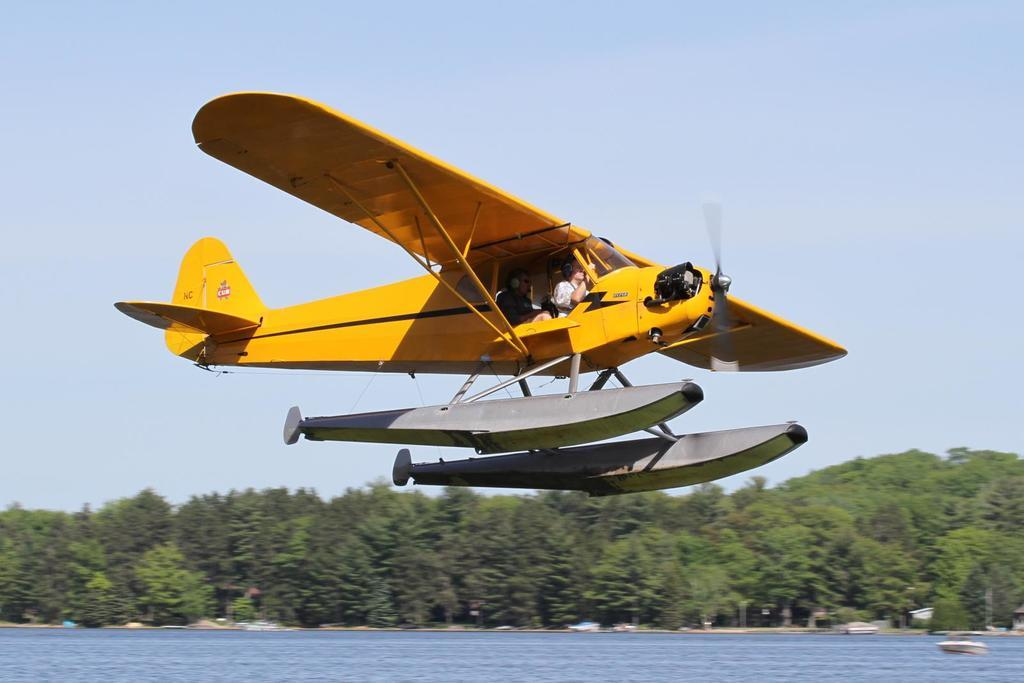What is the main subject of the image? The main subject of the image is a jet plane. What color is the jet plane? The jet plane is yellow. What can be seen at the bottom of the image? There is water at the bottom of the image. What type of vegetation is visible in the background of the image? There are trees in the background of the image. What is visible at the top of the image? The sky is visible at the top of the image. How many canvases are hanging on the trees in the image? There are no canvases present in the image; it features a yellow jet plane, water, trees, and the sky. What type of number is written on the side of the jet plane? There are no numbers visible on the side of the jet plane in the image. 